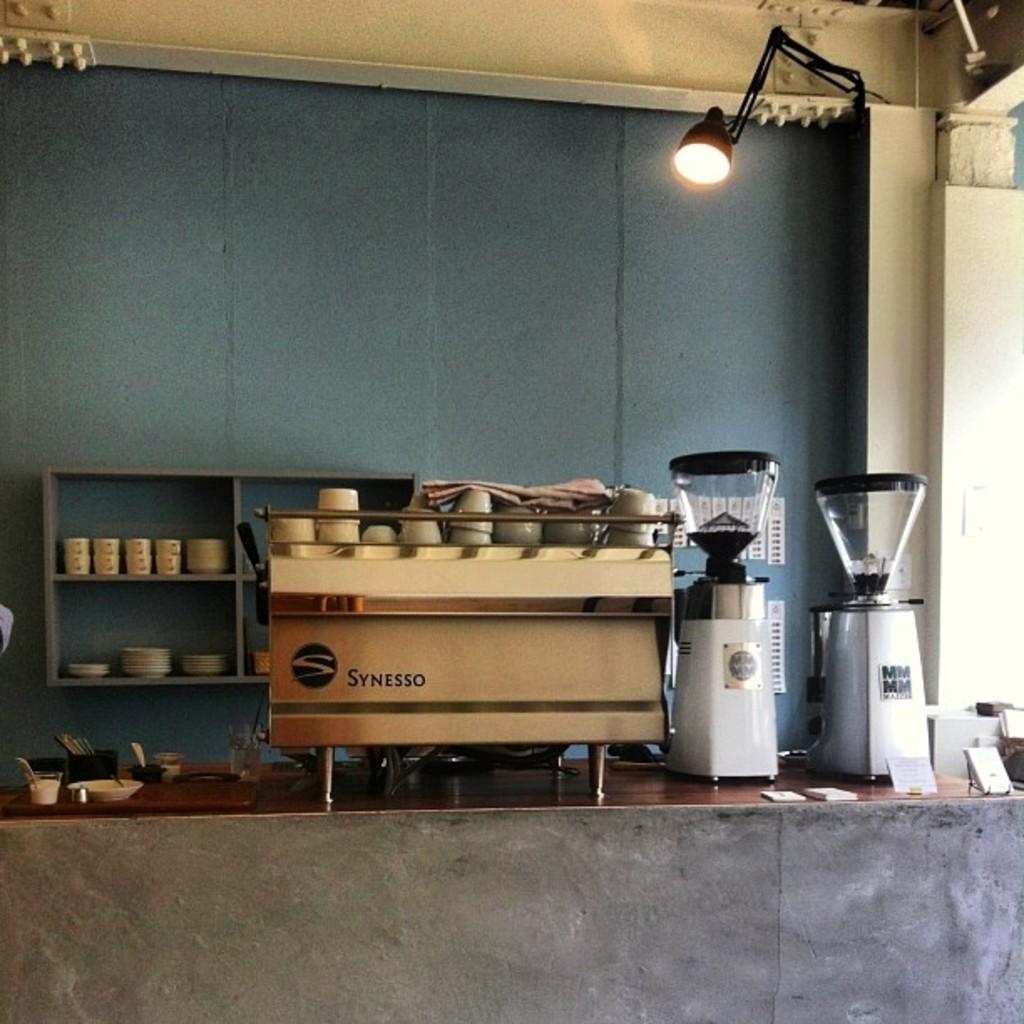What brand is the machine?
Offer a very short reply. Synesso. 